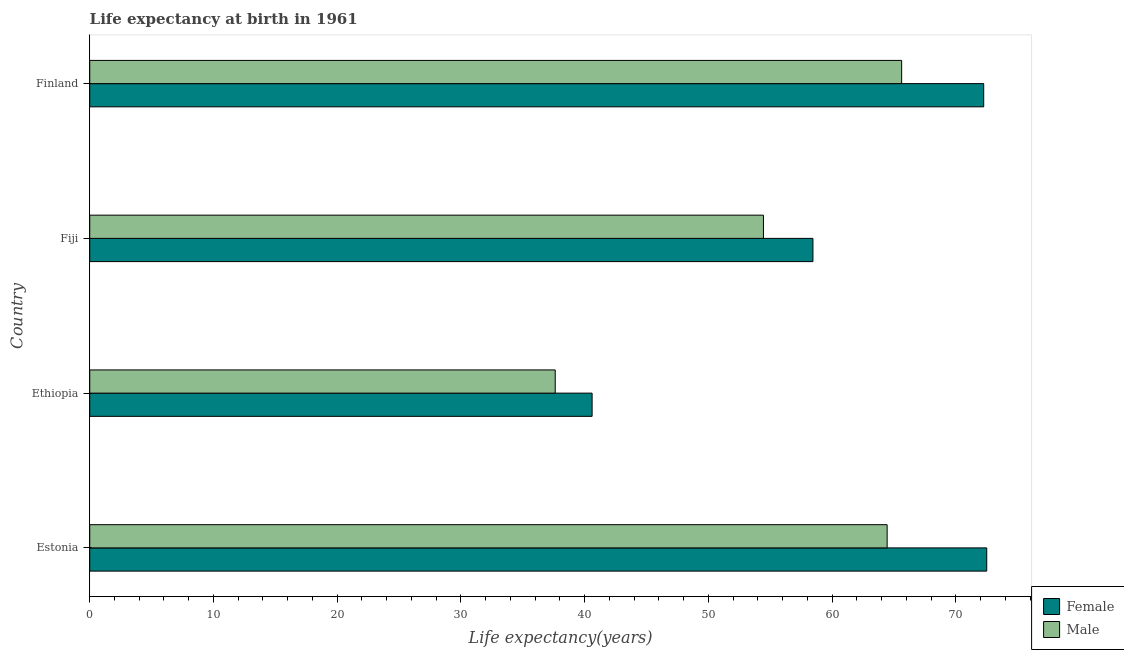How many groups of bars are there?
Make the answer very short. 4. Are the number of bars per tick equal to the number of legend labels?
Offer a terse response. Yes. How many bars are there on the 4th tick from the bottom?
Offer a terse response. 2. What is the label of the 3rd group of bars from the top?
Offer a terse response. Ethiopia. What is the life expectancy(female) in Fiji?
Your answer should be compact. 58.44. Across all countries, what is the maximum life expectancy(female)?
Your answer should be very brief. 72.48. Across all countries, what is the minimum life expectancy(male)?
Your answer should be compact. 37.62. In which country was the life expectancy(female) maximum?
Make the answer very short. Estonia. In which country was the life expectancy(female) minimum?
Your response must be concise. Ethiopia. What is the total life expectancy(female) in the graph?
Provide a succinct answer. 243.76. What is the difference between the life expectancy(male) in Ethiopia and that in Finland?
Offer a very short reply. -28. What is the difference between the life expectancy(female) in Ethiopia and the life expectancy(male) in Finland?
Offer a very short reply. -25.01. What is the average life expectancy(male) per country?
Offer a terse response. 55.53. What is the difference between the life expectancy(male) and life expectancy(female) in Finland?
Your response must be concise. -6.63. In how many countries, is the life expectancy(female) greater than 14 years?
Make the answer very short. 4. What is the ratio of the life expectancy(female) in Estonia to that in Ethiopia?
Your answer should be very brief. 1.79. Is the life expectancy(male) in Ethiopia less than that in Fiji?
Your answer should be very brief. Yes. Is the difference between the life expectancy(male) in Ethiopia and Finland greater than the difference between the life expectancy(female) in Ethiopia and Finland?
Make the answer very short. Yes. What is the difference between the highest and the second highest life expectancy(male)?
Keep it short and to the point. 1.17. What is the difference between the highest and the lowest life expectancy(female)?
Your answer should be compact. 31.89. In how many countries, is the life expectancy(male) greater than the average life expectancy(male) taken over all countries?
Provide a succinct answer. 2. Is the sum of the life expectancy(male) in Estonia and Fiji greater than the maximum life expectancy(female) across all countries?
Ensure brevity in your answer.  Yes. How many bars are there?
Keep it short and to the point. 8. How many countries are there in the graph?
Offer a very short reply. 4. How many legend labels are there?
Your answer should be compact. 2. What is the title of the graph?
Provide a short and direct response. Life expectancy at birth in 1961. What is the label or title of the X-axis?
Provide a succinct answer. Life expectancy(years). What is the label or title of the Y-axis?
Your answer should be very brief. Country. What is the Life expectancy(years) in Female in Estonia?
Your answer should be compact. 72.48. What is the Life expectancy(years) of Male in Estonia?
Provide a succinct answer. 64.44. What is the Life expectancy(years) of Female in Ethiopia?
Keep it short and to the point. 40.6. What is the Life expectancy(years) in Male in Ethiopia?
Offer a terse response. 37.62. What is the Life expectancy(years) in Female in Fiji?
Offer a very short reply. 58.44. What is the Life expectancy(years) of Male in Fiji?
Offer a very short reply. 54.44. What is the Life expectancy(years) in Female in Finland?
Keep it short and to the point. 72.24. What is the Life expectancy(years) in Male in Finland?
Ensure brevity in your answer.  65.61. Across all countries, what is the maximum Life expectancy(years) of Female?
Give a very brief answer. 72.48. Across all countries, what is the maximum Life expectancy(years) of Male?
Your answer should be compact. 65.61. Across all countries, what is the minimum Life expectancy(years) in Female?
Give a very brief answer. 40.6. Across all countries, what is the minimum Life expectancy(years) in Male?
Offer a terse response. 37.62. What is the total Life expectancy(years) in Female in the graph?
Give a very brief answer. 243.76. What is the total Life expectancy(years) of Male in the graph?
Your answer should be very brief. 222.1. What is the difference between the Life expectancy(years) of Female in Estonia and that in Ethiopia?
Your response must be concise. 31.89. What is the difference between the Life expectancy(years) in Male in Estonia and that in Ethiopia?
Make the answer very short. 26.82. What is the difference between the Life expectancy(years) of Female in Estonia and that in Fiji?
Make the answer very short. 14.04. What is the difference between the Life expectancy(years) of Male in Estonia and that in Fiji?
Provide a short and direct response. 9.99. What is the difference between the Life expectancy(years) of Female in Estonia and that in Finland?
Offer a terse response. 0.24. What is the difference between the Life expectancy(years) in Male in Estonia and that in Finland?
Provide a short and direct response. -1.17. What is the difference between the Life expectancy(years) in Female in Ethiopia and that in Fiji?
Keep it short and to the point. -17.84. What is the difference between the Life expectancy(years) of Male in Ethiopia and that in Fiji?
Provide a short and direct response. -16.83. What is the difference between the Life expectancy(years) of Female in Ethiopia and that in Finland?
Your answer should be very brief. -31.64. What is the difference between the Life expectancy(years) of Male in Ethiopia and that in Finland?
Offer a terse response. -28. What is the difference between the Life expectancy(years) in Female in Fiji and that in Finland?
Ensure brevity in your answer.  -13.8. What is the difference between the Life expectancy(years) of Male in Fiji and that in Finland?
Offer a terse response. -11.17. What is the difference between the Life expectancy(years) of Female in Estonia and the Life expectancy(years) of Male in Ethiopia?
Keep it short and to the point. 34.87. What is the difference between the Life expectancy(years) in Female in Estonia and the Life expectancy(years) in Male in Fiji?
Keep it short and to the point. 18.04. What is the difference between the Life expectancy(years) of Female in Estonia and the Life expectancy(years) of Male in Finland?
Make the answer very short. 6.88. What is the difference between the Life expectancy(years) of Female in Ethiopia and the Life expectancy(years) of Male in Fiji?
Make the answer very short. -13.85. What is the difference between the Life expectancy(years) of Female in Ethiopia and the Life expectancy(years) of Male in Finland?
Give a very brief answer. -25.01. What is the difference between the Life expectancy(years) of Female in Fiji and the Life expectancy(years) of Male in Finland?
Provide a succinct answer. -7.17. What is the average Life expectancy(years) of Female per country?
Your answer should be compact. 60.94. What is the average Life expectancy(years) of Male per country?
Provide a succinct answer. 55.53. What is the difference between the Life expectancy(years) in Female and Life expectancy(years) in Male in Estonia?
Provide a short and direct response. 8.05. What is the difference between the Life expectancy(years) in Female and Life expectancy(years) in Male in Ethiopia?
Give a very brief answer. 2.98. What is the difference between the Life expectancy(years) in Female and Life expectancy(years) in Male in Fiji?
Your response must be concise. 4. What is the difference between the Life expectancy(years) of Female and Life expectancy(years) of Male in Finland?
Your response must be concise. 6.63. What is the ratio of the Life expectancy(years) of Female in Estonia to that in Ethiopia?
Ensure brevity in your answer.  1.79. What is the ratio of the Life expectancy(years) in Male in Estonia to that in Ethiopia?
Offer a terse response. 1.71. What is the ratio of the Life expectancy(years) of Female in Estonia to that in Fiji?
Your answer should be very brief. 1.24. What is the ratio of the Life expectancy(years) in Male in Estonia to that in Fiji?
Ensure brevity in your answer.  1.18. What is the ratio of the Life expectancy(years) in Male in Estonia to that in Finland?
Give a very brief answer. 0.98. What is the ratio of the Life expectancy(years) in Female in Ethiopia to that in Fiji?
Provide a succinct answer. 0.69. What is the ratio of the Life expectancy(years) of Male in Ethiopia to that in Fiji?
Keep it short and to the point. 0.69. What is the ratio of the Life expectancy(years) of Female in Ethiopia to that in Finland?
Offer a terse response. 0.56. What is the ratio of the Life expectancy(years) of Male in Ethiopia to that in Finland?
Provide a succinct answer. 0.57. What is the ratio of the Life expectancy(years) in Female in Fiji to that in Finland?
Keep it short and to the point. 0.81. What is the ratio of the Life expectancy(years) of Male in Fiji to that in Finland?
Your answer should be very brief. 0.83. What is the difference between the highest and the second highest Life expectancy(years) of Female?
Your answer should be very brief. 0.24. What is the difference between the highest and the second highest Life expectancy(years) in Male?
Keep it short and to the point. 1.17. What is the difference between the highest and the lowest Life expectancy(years) in Female?
Offer a very short reply. 31.89. What is the difference between the highest and the lowest Life expectancy(years) of Male?
Provide a succinct answer. 28. 